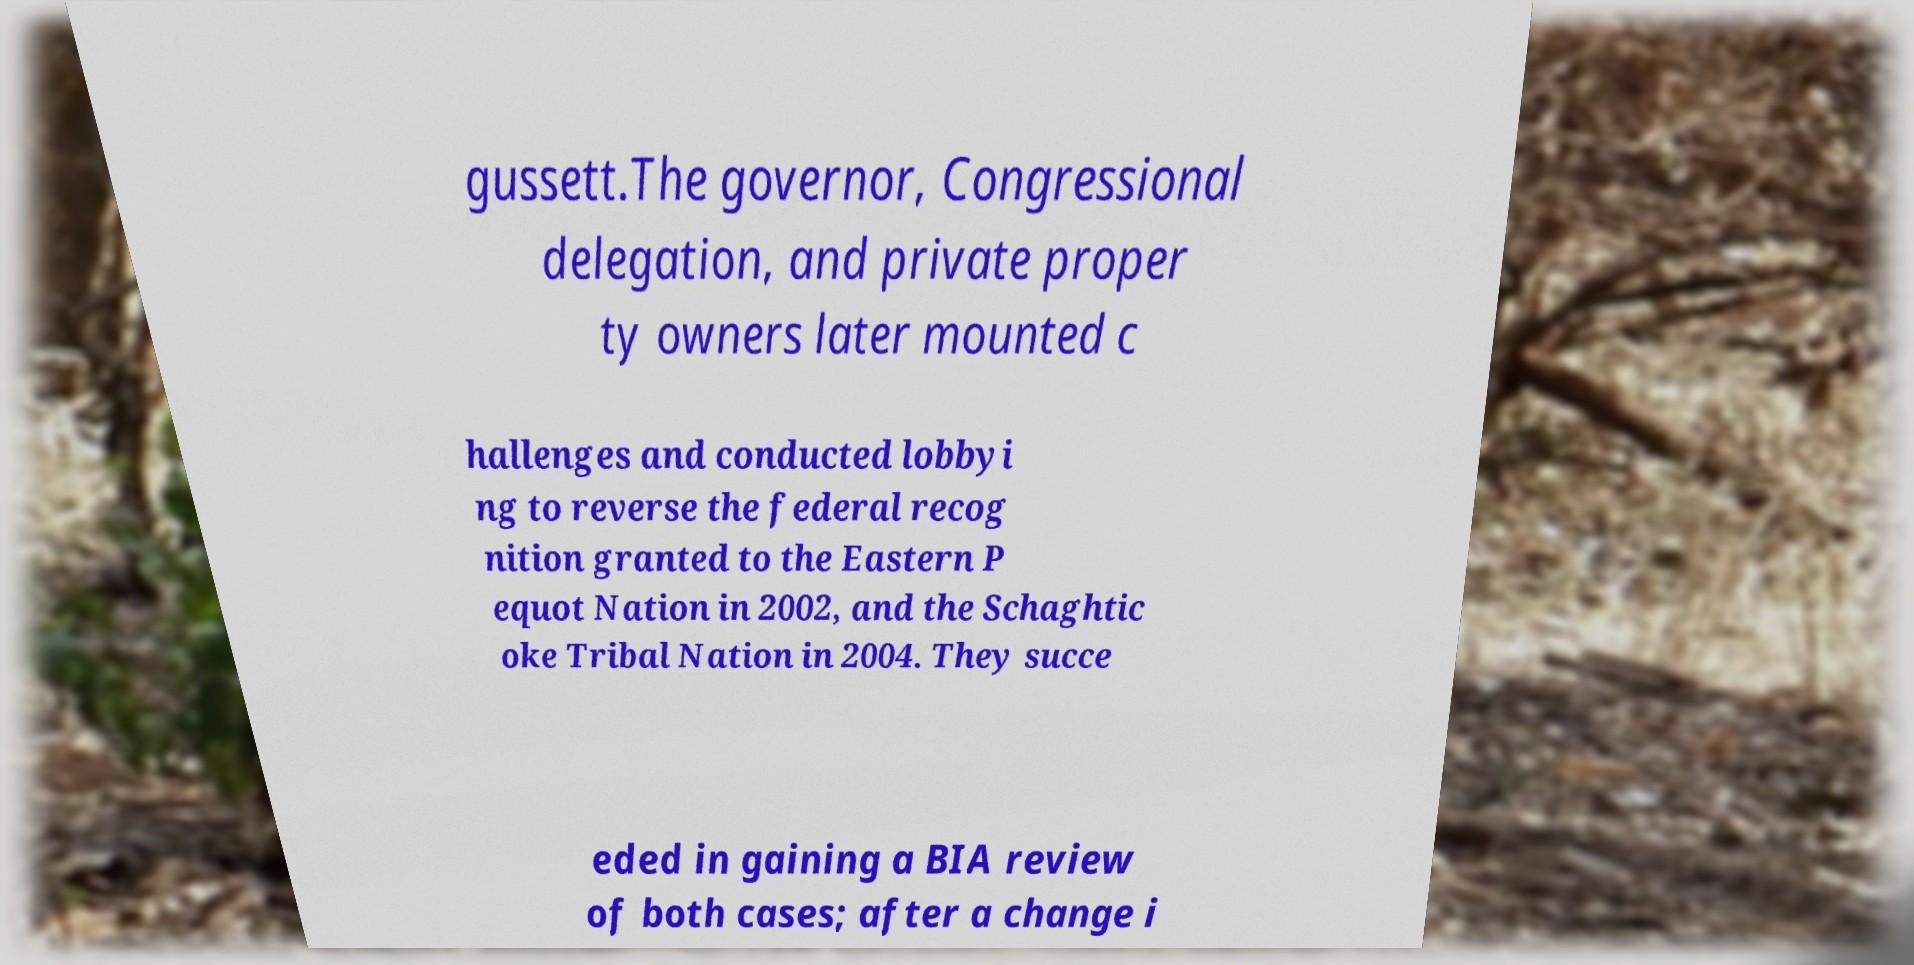Could you extract and type out the text from this image? gussett.The governor, Congressional delegation, and private proper ty owners later mounted c hallenges and conducted lobbyi ng to reverse the federal recog nition granted to the Eastern P equot Nation in 2002, and the Schaghtic oke Tribal Nation in 2004. They succe eded in gaining a BIA review of both cases; after a change i 